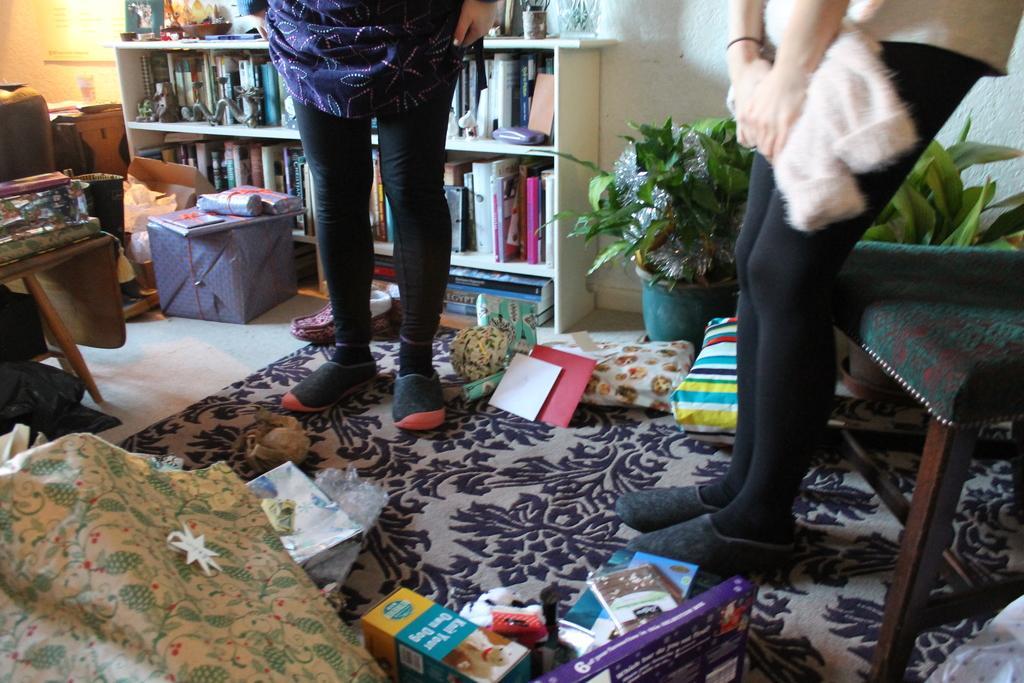Could you give a brief overview of what you see in this image? In this picture there are two members standing on the carpet which is on the floor. There are some books, pillows and some boxes placed on the carpet. In the background there is a shelf in which some books were placed. There is a chair, plants and a wall here. 